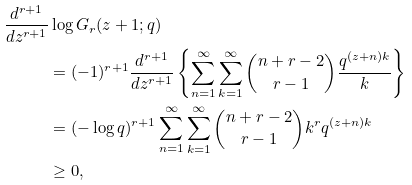<formula> <loc_0><loc_0><loc_500><loc_500>\frac { d ^ { r + 1 } } { d z ^ { r + 1 } } & \log G _ { r } ( z + 1 ; q ) \\ & = ( - 1 ) ^ { r + 1 } \frac { d ^ { r + 1 } } { d z ^ { r + 1 } } \left \{ \sum _ { n = 1 } ^ { \infty } \sum _ { k = 1 } ^ { \infty } \binom { n + r - 2 } { r - 1 } \frac { q ^ { ( z + n ) k } } { k } \right \} \\ & = ( - \log q ) ^ { r + 1 } \sum _ { n = 1 } ^ { \infty } \sum _ { k = 1 } ^ { \infty } \binom { n + r - 2 } { r - 1 } k ^ { r } q ^ { ( z + n ) k } \\ & \geq 0 ,</formula> 